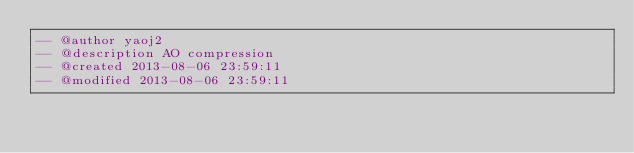<code> <loc_0><loc_0><loc_500><loc_500><_SQL_>-- @author yaoj2
-- @description AO compression
-- @created 2013-08-06 23:59:11
-- @modified 2013-08-06 23:59:11</code> 